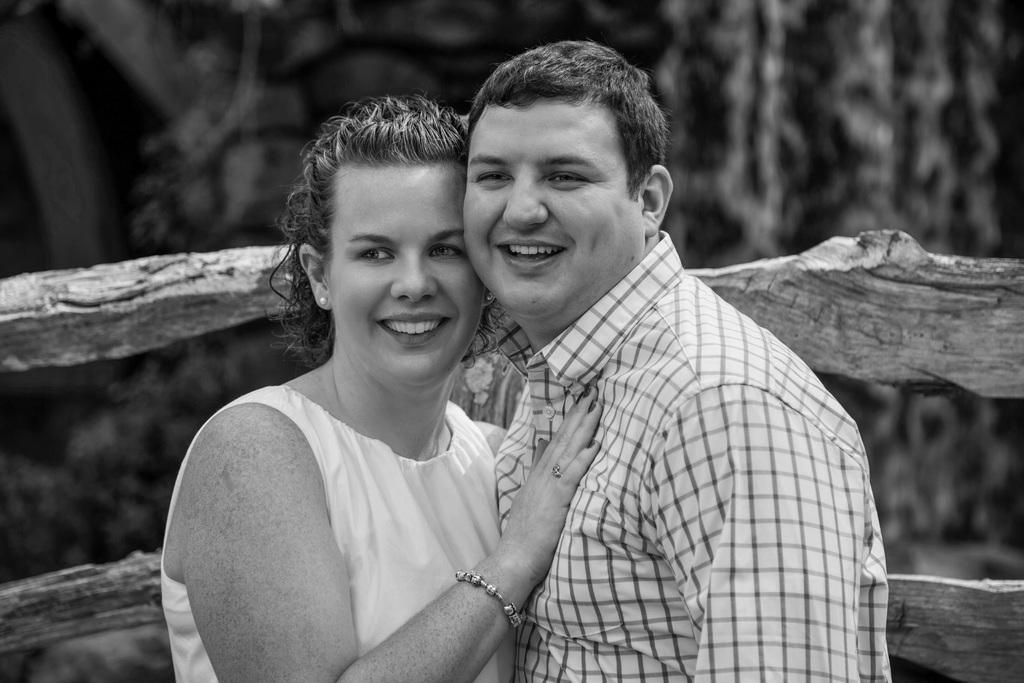How would you summarize this image in a sentence or two? In this image we can see man and woman wearing white color dress standing and hugging each other and in the background of the image there is fencing. 